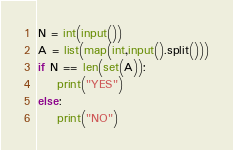Convert code to text. <code><loc_0><loc_0><loc_500><loc_500><_Python_>N = int(input())
A = list(map(int,input().split()))
if N == len(set(A)):
    print("YES")
else:
    print("NO")</code> 